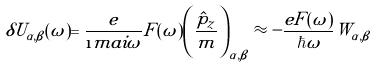Convert formula to latex. <formula><loc_0><loc_0><loc_500><loc_500>\delta U _ { \alpha , \beta } ( \omega ) = \frac { e } { \i m a i \omega } F ( \omega ) \left ( \frac { \hat { p } _ { z } } { m } \right ) _ { \alpha , \beta } \approx - \frac { e F ( \omega ) } { \hbar { \omega } } W _ { \alpha , \beta }</formula> 